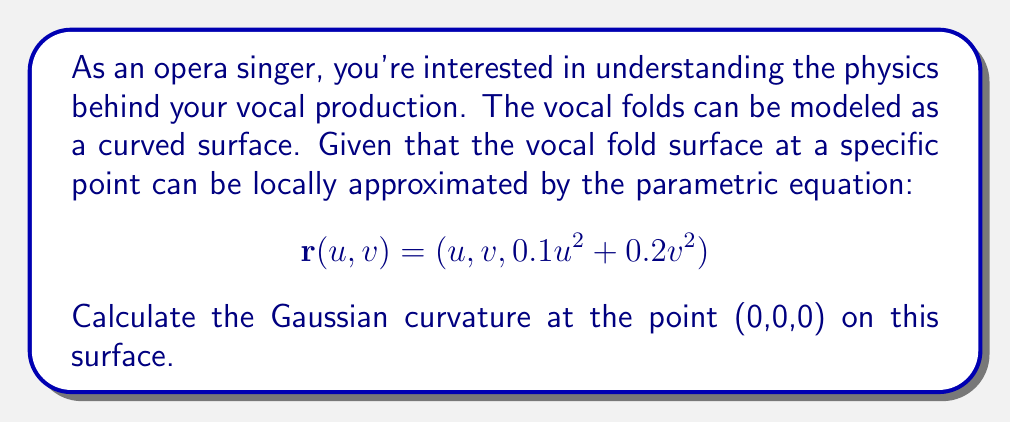Can you answer this question? To calculate the Gaussian curvature of the vocal fold surface, we'll follow these steps:

1) First, we need to calculate the first fundamental form coefficients (E, F, G) and the second fundamental form coefficients (L, M, N).

2) The partial derivatives of $\mathbf{r}$ are:
   $$\mathbf{r}_u = (1, 0, 0.2u)$$
   $$\mathbf{r}_v = (0, 1, 0.4v)$$

3) At the point (0,0,0), these become:
   $$\mathbf{r}_u = (1, 0, 0)$$
   $$\mathbf{r}_v = (0, 1, 0)$$

4) The coefficients of the first fundamental form at (0,0,0) are:
   $$E = \mathbf{r}_u \cdot \mathbf{r}_u = 1$$
   $$F = \mathbf{r}_u \cdot \mathbf{r}_v = 0$$
   $$G = \mathbf{r}_v \cdot \mathbf{r}_v = 1$$

5) The second partial derivatives are:
   $$\mathbf{r}_{uu} = (0, 0, 0.2)$$
   $$\mathbf{r}_{uv} = (0, 0, 0)$$
   $$\mathbf{r}_{vv} = (0, 0, 0.4)$$

6) The unit normal vector at (0,0,0) is:
   $$\mathbf{N} = \frac{\mathbf{r}_u \times \mathbf{r}_v}{|\mathbf{r}_u \times \mathbf{r}_v|} = (0, 0, 1)$$

7) The coefficients of the second fundamental form at (0,0,0) are:
   $$L = \mathbf{r}_{uu} \cdot \mathbf{N} = 0.2$$
   $$M = \mathbf{r}_{uv} \cdot \mathbf{N} = 0$$
   $$N = \mathbf{r}_{vv} \cdot \mathbf{N} = 0.4$$

8) The Gaussian curvature K is given by:
   $$K = \frac{LN - M^2}{EG - F^2}$$

9) Substituting the values:
   $$K = \frac{(0.2)(0.4) - 0^2}{(1)(1) - 0^2} = 0.08$$

Therefore, the Gaussian curvature at the point (0,0,0) on the vocal fold surface is 0.08.
Answer: The Gaussian curvature at the point (0,0,0) on the given vocal fold surface is 0.08. 